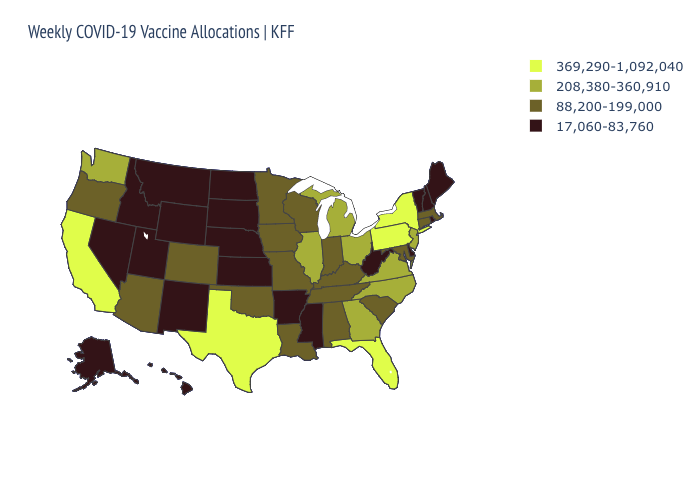Among the states that border Utah , which have the highest value?
Quick response, please. Arizona, Colorado. Does Kansas have the lowest value in the MidWest?
Concise answer only. Yes. Name the states that have a value in the range 88,200-199,000?
Keep it brief. Alabama, Arizona, Colorado, Connecticut, Indiana, Iowa, Kentucky, Louisiana, Maryland, Massachusetts, Minnesota, Missouri, Oklahoma, Oregon, South Carolina, Tennessee, Wisconsin. What is the lowest value in the USA?
Keep it brief. 17,060-83,760. Name the states that have a value in the range 88,200-199,000?
Quick response, please. Alabama, Arizona, Colorado, Connecticut, Indiana, Iowa, Kentucky, Louisiana, Maryland, Massachusetts, Minnesota, Missouri, Oklahoma, Oregon, South Carolina, Tennessee, Wisconsin. What is the value of Arkansas?
Answer briefly. 17,060-83,760. What is the value of Kentucky?
Short answer required. 88,200-199,000. Among the states that border Oklahoma , which have the highest value?
Answer briefly. Texas. Does the first symbol in the legend represent the smallest category?
Write a very short answer. No. What is the value of Oklahoma?
Keep it brief. 88,200-199,000. Does Minnesota have the lowest value in the USA?
Concise answer only. No. Does Missouri have the same value as Kentucky?
Be succinct. Yes. Name the states that have a value in the range 208,380-360,910?
Give a very brief answer. Georgia, Illinois, Michigan, New Jersey, North Carolina, Ohio, Virginia, Washington. Does California have the highest value in the USA?
Answer briefly. Yes. Which states hav the highest value in the Northeast?
Quick response, please. New York, Pennsylvania. 